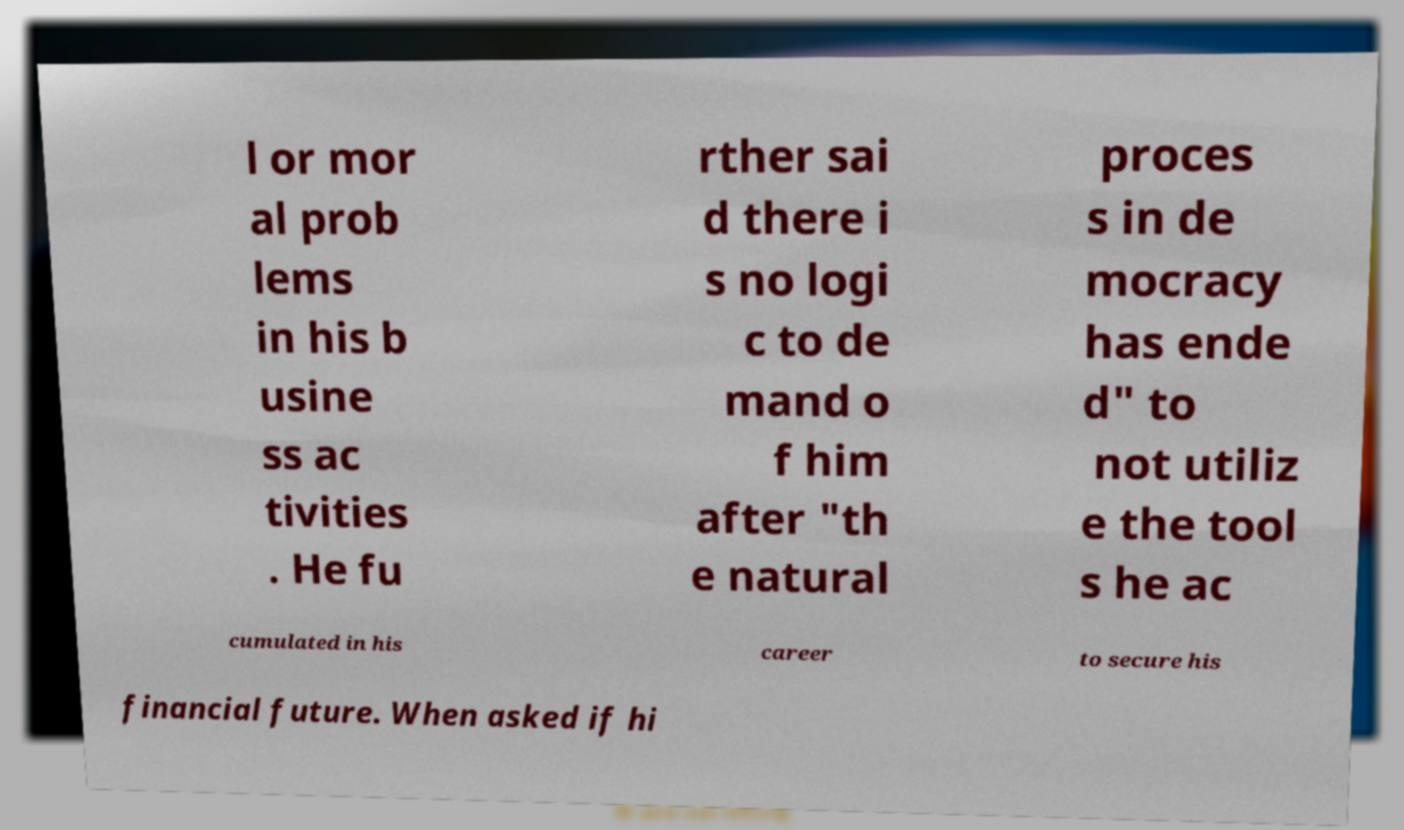What messages or text are displayed in this image? I need them in a readable, typed format. l or mor al prob lems in his b usine ss ac tivities . He fu rther sai d there i s no logi c to de mand o f him after "th e natural proces s in de mocracy has ende d" to not utiliz e the tool s he ac cumulated in his career to secure his financial future. When asked if hi 